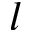Convert formula to latex. <formula><loc_0><loc_0><loc_500><loc_500>l</formula> 